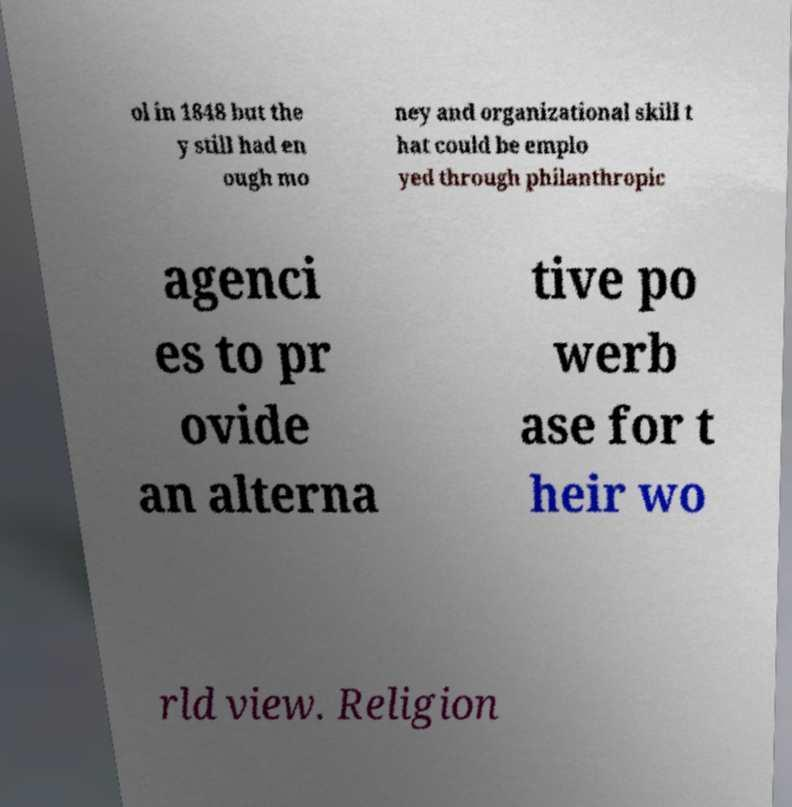Can you read and provide the text displayed in the image?This photo seems to have some interesting text. Can you extract and type it out for me? ol in 1848 but the y still had en ough mo ney and organizational skill t hat could be emplo yed through philanthropic agenci es to pr ovide an alterna tive po werb ase for t heir wo rld view. Religion 